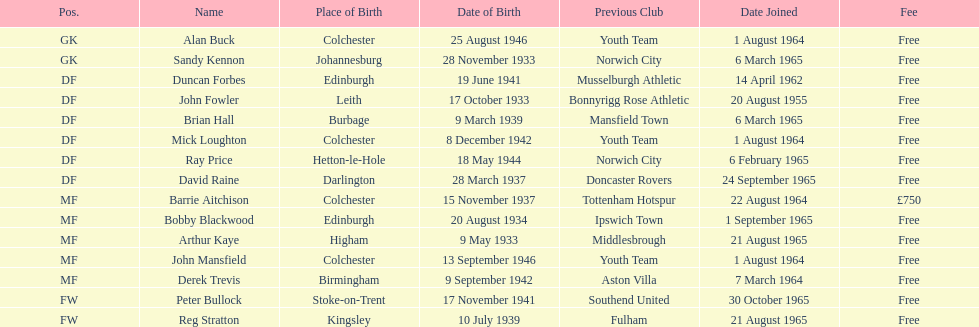Name the player whose fee was not free. Barrie Aitchison. 